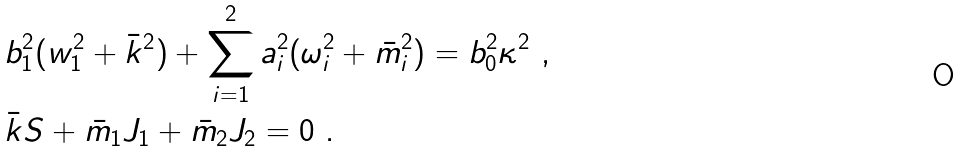Convert formula to latex. <formula><loc_0><loc_0><loc_500><loc_500>& b _ { 1 } ^ { 2 } ( w _ { 1 } ^ { 2 } + \bar { k } ^ { 2 } ) + \sum _ { i = 1 } ^ { 2 } a _ { i } ^ { 2 } ( \omega ^ { 2 } _ { i } + \bar { m } ^ { 2 } _ { i } ) = b _ { 0 } ^ { 2 } \kappa ^ { 2 } \ , \\ & \bar { k } S + \bar { m } _ { 1 } J _ { 1 } + \bar { m } _ { 2 } J _ { 2 } = 0 \ .</formula> 